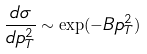<formula> <loc_0><loc_0><loc_500><loc_500>\frac { d \sigma } { d p _ { T } ^ { 2 } } \sim \exp ( - B p _ { T } ^ { 2 } )</formula> 